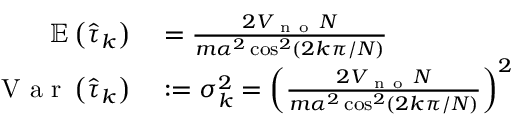<formula> <loc_0><loc_0><loc_500><loc_500>\begin{array} { r l } { \mathbb { E } \left ( \hat { \tau } _ { k } \right ) } & = \frac { 2 V _ { n o } N } { m \alpha ^ { 2 } \cos ^ { 2 } \left ( 2 k \pi / N \right ) } } \\ { V a r \left ( \hat { \tau } _ { k } \right ) } & \colon = \sigma _ { k } ^ { 2 } = \left ( \frac { 2 V _ { n o } N } { m \alpha ^ { 2 } \cos ^ { 2 } \left ( 2 k \pi / N \right ) } \right ) ^ { 2 } } \end{array}</formula> 